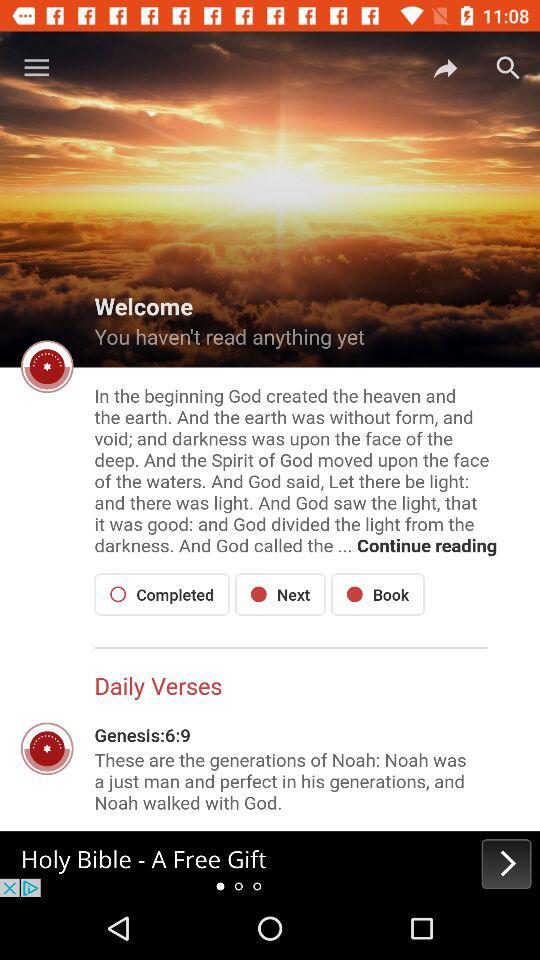How many verses have been read?
Answer the question using a single word or phrase. 0 